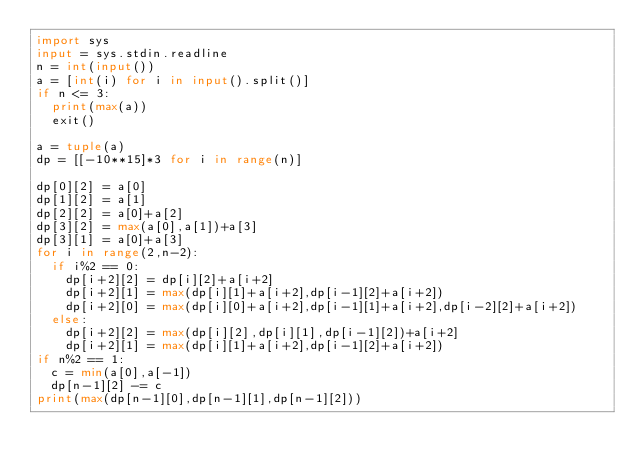Convert code to text. <code><loc_0><loc_0><loc_500><loc_500><_Python_>import sys
input = sys.stdin.readline
n = int(input())
a = [int(i) for i in input().split()]
if n <= 3:
  print(max(a))
  exit()

a = tuple(a)
dp = [[-10**15]*3 for i in range(n)]

dp[0][2] = a[0]
dp[1][2] = a[1]
dp[2][2] = a[0]+a[2]
dp[3][2] = max(a[0],a[1])+a[3]
dp[3][1] = a[0]+a[3]
for i in range(2,n-2):
  if i%2 == 0:
    dp[i+2][2] = dp[i][2]+a[i+2]
    dp[i+2][1] = max(dp[i][1]+a[i+2],dp[i-1][2]+a[i+2])
    dp[i+2][0] = max(dp[i][0]+a[i+2],dp[i-1][1]+a[i+2],dp[i-2][2]+a[i+2])
  else:
    dp[i+2][2] = max(dp[i][2],dp[i][1],dp[i-1][2])+a[i+2]
    dp[i+2][1] = max(dp[i][1]+a[i+2],dp[i-1][2]+a[i+2])
if n%2 == 1:
  c = min(a[0],a[-1])
  dp[n-1][2] -= c
print(max(dp[n-1][0],dp[n-1][1],dp[n-1][2]))</code> 